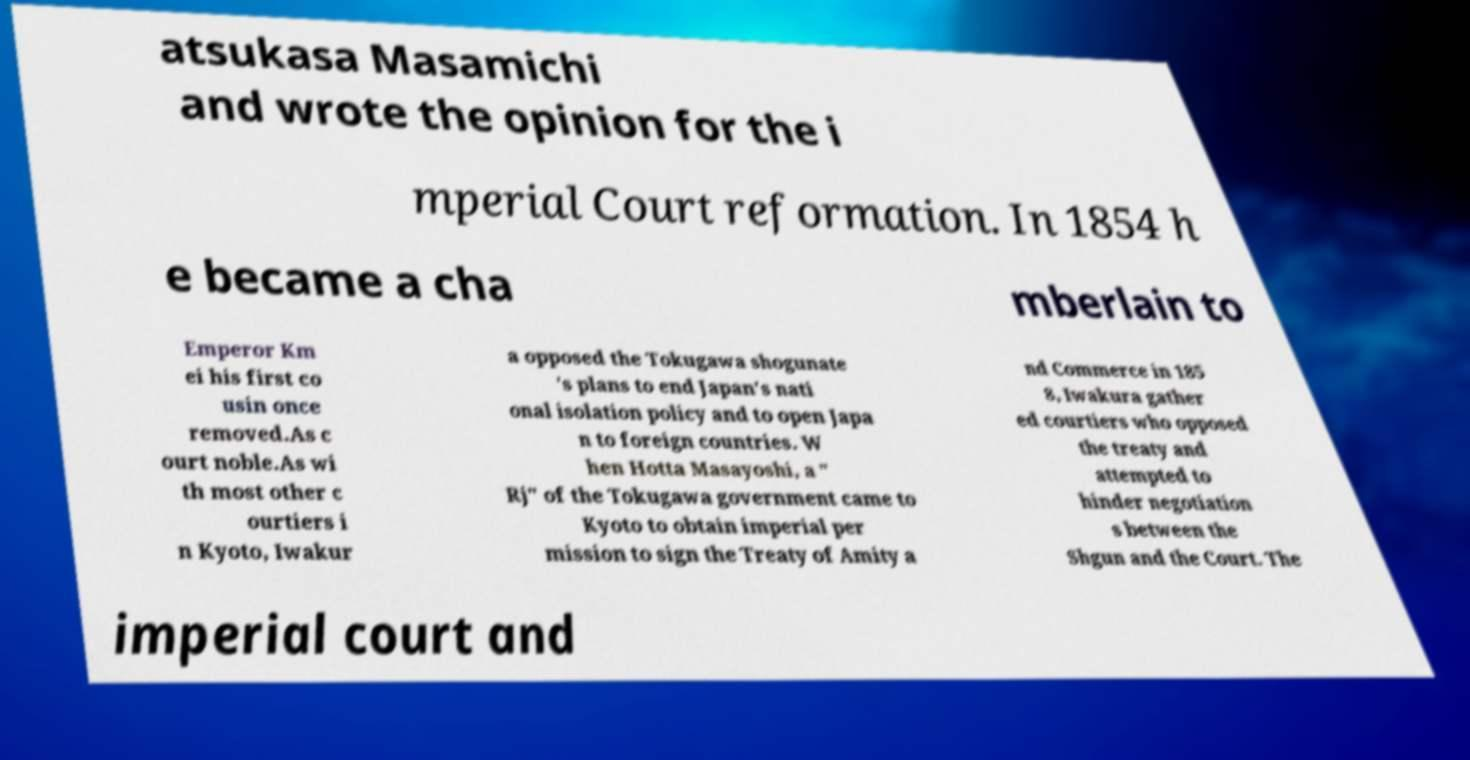Can you accurately transcribe the text from the provided image for me? atsukasa Masamichi and wrote the opinion for the i mperial Court reformation. In 1854 h e became a cha mberlain to Emperor Km ei his first co usin once removed.As c ourt noble.As wi th most other c ourtiers i n Kyoto, Iwakur a opposed the Tokugawa shogunate 's plans to end Japan's nati onal isolation policy and to open Japa n to foreign countries. W hen Hotta Masayoshi, a " Rj" of the Tokugawa government came to Kyoto to obtain imperial per mission to sign the Treaty of Amity a nd Commerce in 185 8, Iwakura gather ed courtiers who opposed the treaty and attempted to hinder negotiation s between the Shgun and the Court. The imperial court and 